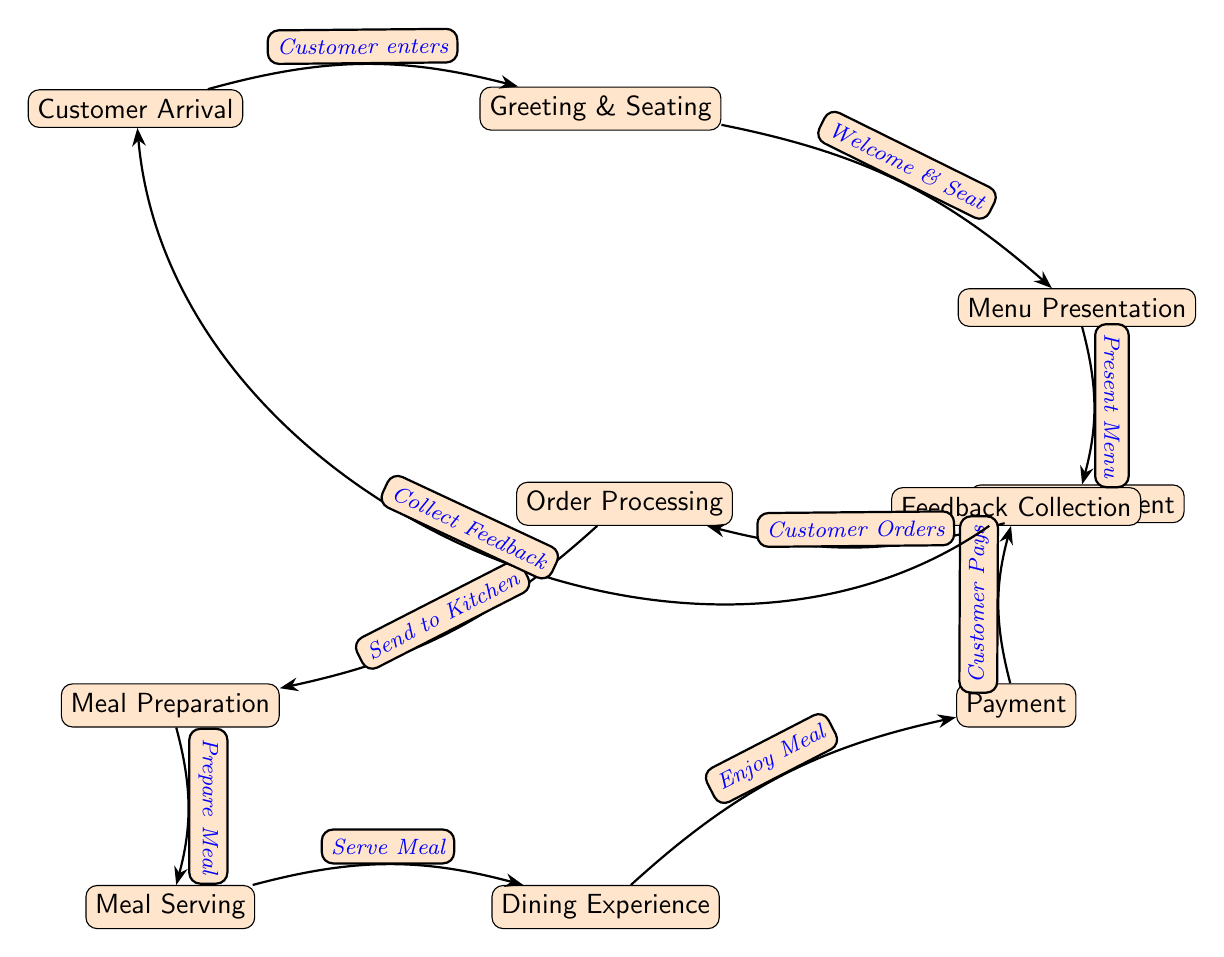What is the first step in the customer journey? The first step in the customer journey is depicted as the "Customer Arrival" node, indicating when a customer arrives at the restaurant.
Answer: Customer Arrival How many nodes are present in the diagram? The diagram consists of a total of eleven nodes, representing various stages in the customer journey, from arrival to feedback collection.
Answer: Eleven What action occurs after "Meal Serving"? After "Meal Serving," the next action is "Dining Experience," indicating that the meal is now being enjoyed by the customer.
Answer: Dining Experience What node directly follows "Order Placement"? The node that directly follows "Order Placement" is "Order Processing," indicating that the order is being handled after it is placed.
Answer: Order Processing Which node is responsible for collecting customer feedback? The "Feedback Collection" node is responsible for gathering feedback from the customer after the dining experience.
Answer: Feedback Collection What is the relationship between "Payment" and "Dining Experience"? The relationship indicated is "Customer Pays," meaning that payment occurs after the dining experience is completed.
Answer: Customer Pays In which step does the customer enjoy their meal? The customer enjoys their meal during the "Dining Experience" step, which directly follows "Meal Serving."
Answer: Dining Experience Which two nodes are connected by the action "Prepare Meal"? The "Prepare Meal" action connects the nodes "Meal Preparation" and "Meal Serving," indicating the flow from preparation to serving.
Answer: Meal Preparation and Meal Serving What is the last step before collecting feedback? The last step before collecting feedback is "Payment," where the customer completes the payment process.
Answer: Payment 